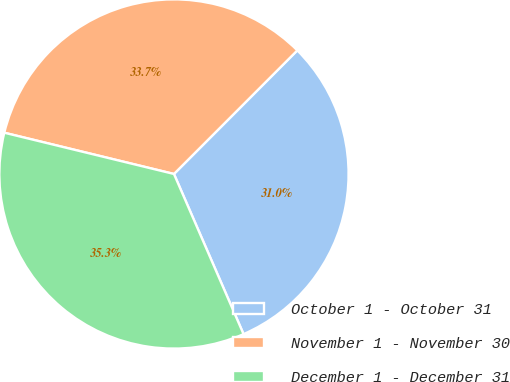Convert chart. <chart><loc_0><loc_0><loc_500><loc_500><pie_chart><fcel>October 1 - October 31<fcel>November 1 - November 30<fcel>December 1 - December 31<nl><fcel>30.99%<fcel>33.69%<fcel>35.32%<nl></chart> 